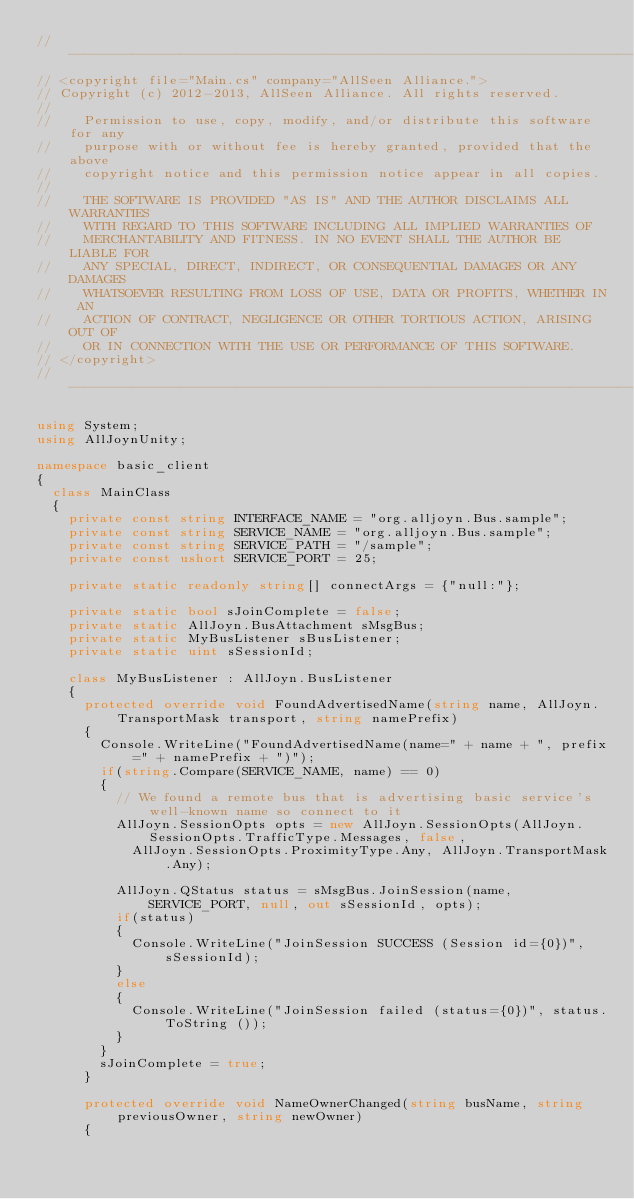Convert code to text. <code><loc_0><loc_0><loc_500><loc_500><_C#_>//-----------------------------------------------------------------------
// <copyright file="Main.cs" company="AllSeen Alliance.">
// Copyright (c) 2012-2013, AllSeen Alliance. All rights reserved.
//
//    Permission to use, copy, modify, and/or distribute this software for any
//    purpose with or without fee is hereby granted, provided that the above
//    copyright notice and this permission notice appear in all copies.
//
//    THE SOFTWARE IS PROVIDED "AS IS" AND THE AUTHOR DISCLAIMS ALL WARRANTIES
//    WITH REGARD TO THIS SOFTWARE INCLUDING ALL IMPLIED WARRANTIES OF
//    MERCHANTABILITY AND FITNESS. IN NO EVENT SHALL THE AUTHOR BE LIABLE FOR
//    ANY SPECIAL, DIRECT, INDIRECT, OR CONSEQUENTIAL DAMAGES OR ANY DAMAGES
//    WHATSOEVER RESULTING FROM LOSS OF USE, DATA OR PROFITS, WHETHER IN AN
//    ACTION OF CONTRACT, NEGLIGENCE OR OTHER TORTIOUS ACTION, ARISING OUT OF
//    OR IN CONNECTION WITH THE USE OR PERFORMANCE OF THIS SOFTWARE.
// </copyright>
//-----------------------------------------------------------------------

using System;
using AllJoynUnity;

namespace basic_client
{
	class MainClass
	{
		private const string INTERFACE_NAME = "org.alljoyn.Bus.sample";
		private const string SERVICE_NAME = "org.alljoyn.Bus.sample";
		private const string SERVICE_PATH = "/sample";
		private const ushort SERVICE_PORT = 25;

		private static readonly string[] connectArgs = {"null:"};

		private static bool sJoinComplete = false;
		private static AllJoyn.BusAttachment sMsgBus;
		private static MyBusListener sBusListener;
		private static uint sSessionId;

		class MyBusListener : AllJoyn.BusListener
		{
			protected override void FoundAdvertisedName(string name, AllJoyn.TransportMask transport, string namePrefix)
			{
				Console.WriteLine("FoundAdvertisedName(name=" + name + ", prefix=" + namePrefix + ")");
				if(string.Compare(SERVICE_NAME, name) == 0)
				{
					// We found a remote bus that is advertising basic service's  well-known name so connect to it
					AllJoyn.SessionOpts opts = new AllJoyn.SessionOpts(AllJoyn.SessionOpts.TrafficType.Messages, false,
						AllJoyn.SessionOpts.ProximityType.Any, AllJoyn.TransportMask.Any);

					AllJoyn.QStatus status = sMsgBus.JoinSession(name, SERVICE_PORT, null, out sSessionId, opts);
					if(status)
					{
						Console.WriteLine("JoinSession SUCCESS (Session id={0})", sSessionId);
					}
					else
					{
						Console.WriteLine("JoinSession failed (status={0})", status.ToString ());
					}
				}
				sJoinComplete = true;
			}

			protected override void NameOwnerChanged(string busName, string previousOwner, string newOwner)
			{</code> 